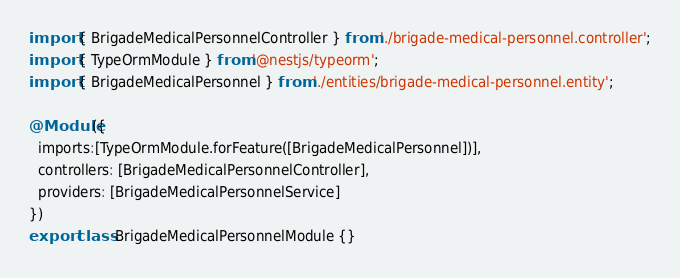<code> <loc_0><loc_0><loc_500><loc_500><_TypeScript_>import { BrigadeMedicalPersonnelController } from './brigade-medical-personnel.controller';
import { TypeOrmModule } from '@nestjs/typeorm';
import { BrigadeMedicalPersonnel } from './entities/brigade-medical-personnel.entity';

@Module({
  imports:[TypeOrmModule.forFeature([BrigadeMedicalPersonnel])],
  controllers: [BrigadeMedicalPersonnelController],
  providers: [BrigadeMedicalPersonnelService]
})
export class BrigadeMedicalPersonnelModule {}
</code> 